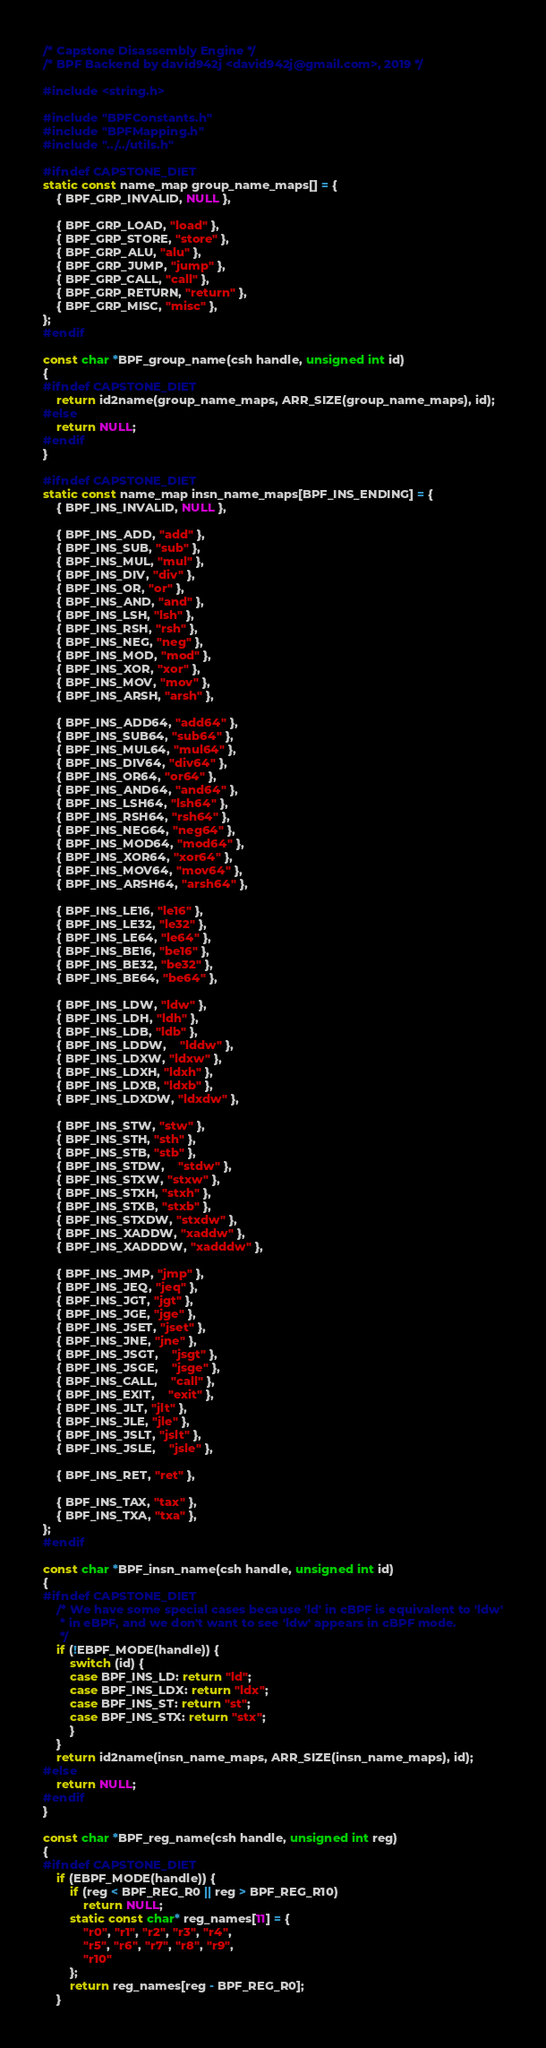<code> <loc_0><loc_0><loc_500><loc_500><_C_>/* Capstone Disassembly Engine */
/* BPF Backend by david942j <david942j@gmail.com>, 2019 */

#include <string.h>

#include "BPFConstants.h"
#include "BPFMapping.h"
#include "../../utils.h"

#ifndef CAPSTONE_DIET
static const name_map group_name_maps[] = {
	{ BPF_GRP_INVALID, NULL },

	{ BPF_GRP_LOAD, "load" },
	{ BPF_GRP_STORE, "store" },
	{ BPF_GRP_ALU, "alu" },
	{ BPF_GRP_JUMP, "jump" },
	{ BPF_GRP_CALL, "call" },
	{ BPF_GRP_RETURN, "return" },
	{ BPF_GRP_MISC, "misc" },
};
#endif

const char *BPF_group_name(csh handle, unsigned int id)
{
#ifndef CAPSTONE_DIET
	return id2name(group_name_maps, ARR_SIZE(group_name_maps), id);
#else
	return NULL;
#endif
}

#ifndef CAPSTONE_DIET
static const name_map insn_name_maps[BPF_INS_ENDING] = {
	{ BPF_INS_INVALID, NULL },

	{ BPF_INS_ADD, "add" },
	{ BPF_INS_SUB, "sub" },
	{ BPF_INS_MUL, "mul" },
	{ BPF_INS_DIV, "div" },
	{ BPF_INS_OR, "or" },
	{ BPF_INS_AND, "and" },
	{ BPF_INS_LSH, "lsh" },
	{ BPF_INS_RSH, "rsh" },
	{ BPF_INS_NEG, "neg" },
	{ BPF_INS_MOD, "mod" },
	{ BPF_INS_XOR, "xor" },
	{ BPF_INS_MOV, "mov" },
	{ BPF_INS_ARSH, "arsh" },

	{ BPF_INS_ADD64, "add64" },
	{ BPF_INS_SUB64, "sub64" },
	{ BPF_INS_MUL64, "mul64" },
	{ BPF_INS_DIV64, "div64" },
	{ BPF_INS_OR64, "or64" },
	{ BPF_INS_AND64, "and64" },
	{ BPF_INS_LSH64, "lsh64" },
	{ BPF_INS_RSH64, "rsh64" },
	{ BPF_INS_NEG64, "neg64" },
	{ BPF_INS_MOD64, "mod64" },
	{ BPF_INS_XOR64, "xor64" },
	{ BPF_INS_MOV64, "mov64" },
	{ BPF_INS_ARSH64, "arsh64" },

	{ BPF_INS_LE16, "le16" },
	{ BPF_INS_LE32, "le32" },
	{ BPF_INS_LE64, "le64" },
	{ BPF_INS_BE16, "be16" },
	{ BPF_INS_BE32, "be32" },
	{ BPF_INS_BE64, "be64" },

	{ BPF_INS_LDW, "ldw" },
	{ BPF_INS_LDH, "ldh" },
	{ BPF_INS_LDB, "ldb" },
	{ BPF_INS_LDDW,	"lddw" },
	{ BPF_INS_LDXW, "ldxw" },
	{ BPF_INS_LDXH, "ldxh" },
	{ BPF_INS_LDXB, "ldxb" },
	{ BPF_INS_LDXDW, "ldxdw" },

	{ BPF_INS_STW, "stw" },
	{ BPF_INS_STH, "sth" },
	{ BPF_INS_STB, "stb" },
	{ BPF_INS_STDW,	"stdw" },
	{ BPF_INS_STXW, "stxw" },
	{ BPF_INS_STXH, "stxh" },
	{ BPF_INS_STXB, "stxb" },
	{ BPF_INS_STXDW, "stxdw" },
	{ BPF_INS_XADDW, "xaddw" },
	{ BPF_INS_XADDDW, "xadddw" },

	{ BPF_INS_JMP, "jmp" },
	{ BPF_INS_JEQ, "jeq" },
	{ BPF_INS_JGT, "jgt" },
	{ BPF_INS_JGE, "jge" },
	{ BPF_INS_JSET, "jset" },
	{ BPF_INS_JNE, "jne" },
	{ BPF_INS_JSGT,	"jsgt" },
	{ BPF_INS_JSGE,	"jsge" },
	{ BPF_INS_CALL,	"call" },
	{ BPF_INS_EXIT,	"exit" },
	{ BPF_INS_JLT, "jlt" },
	{ BPF_INS_JLE, "jle" },
	{ BPF_INS_JSLT, "jslt" },
	{ BPF_INS_JSLE,	"jsle" },

	{ BPF_INS_RET, "ret" },

	{ BPF_INS_TAX, "tax" },
	{ BPF_INS_TXA, "txa" },
};
#endif

const char *BPF_insn_name(csh handle, unsigned int id)
{
#ifndef CAPSTONE_DIET
	/* We have some special cases because 'ld' in cBPF is equivalent to 'ldw'
	 * in eBPF, and we don't want to see 'ldw' appears in cBPF mode.
	 */
	if (!EBPF_MODE(handle)) {
		switch (id) {
		case BPF_INS_LD: return "ld";
		case BPF_INS_LDX: return "ldx";
		case BPF_INS_ST: return "st";
		case BPF_INS_STX: return "stx";
		}
	}
	return id2name(insn_name_maps, ARR_SIZE(insn_name_maps), id);
#else
	return NULL;
#endif
}

const char *BPF_reg_name(csh handle, unsigned int reg)
{
#ifndef CAPSTONE_DIET
	if (EBPF_MODE(handle)) {
		if (reg < BPF_REG_R0 || reg > BPF_REG_R10)
			return NULL;
		static const char* reg_names[11] = {
			"r0", "r1", "r2", "r3", "r4",
			"r5", "r6", "r7", "r8", "r9",
			"r10"
		};
		return reg_names[reg - BPF_REG_R0];
	}
</code> 